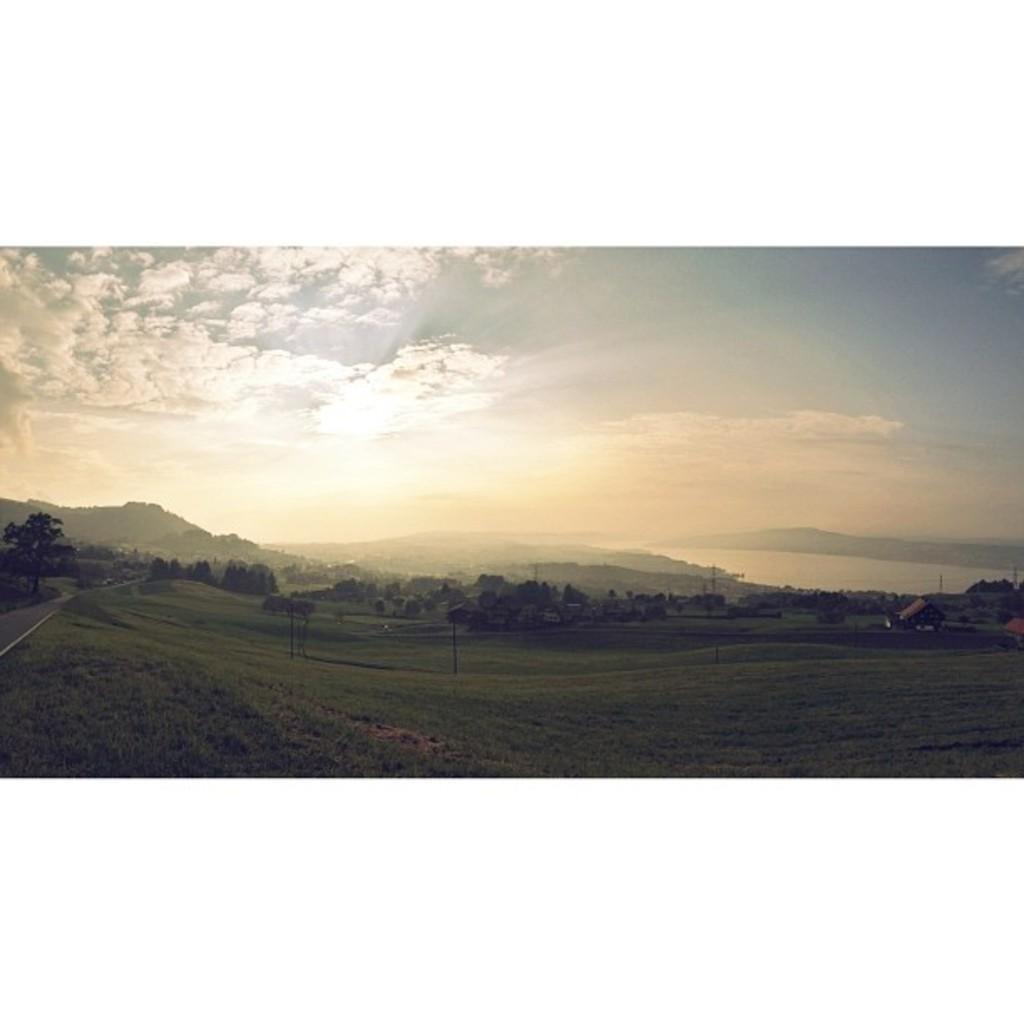Please provide a concise description of this image. In this image we can see a large group of tree, houses with roof, grass and a pathway. On the backside we can see the mountains, a large water body and the sky which looks cloudy. 